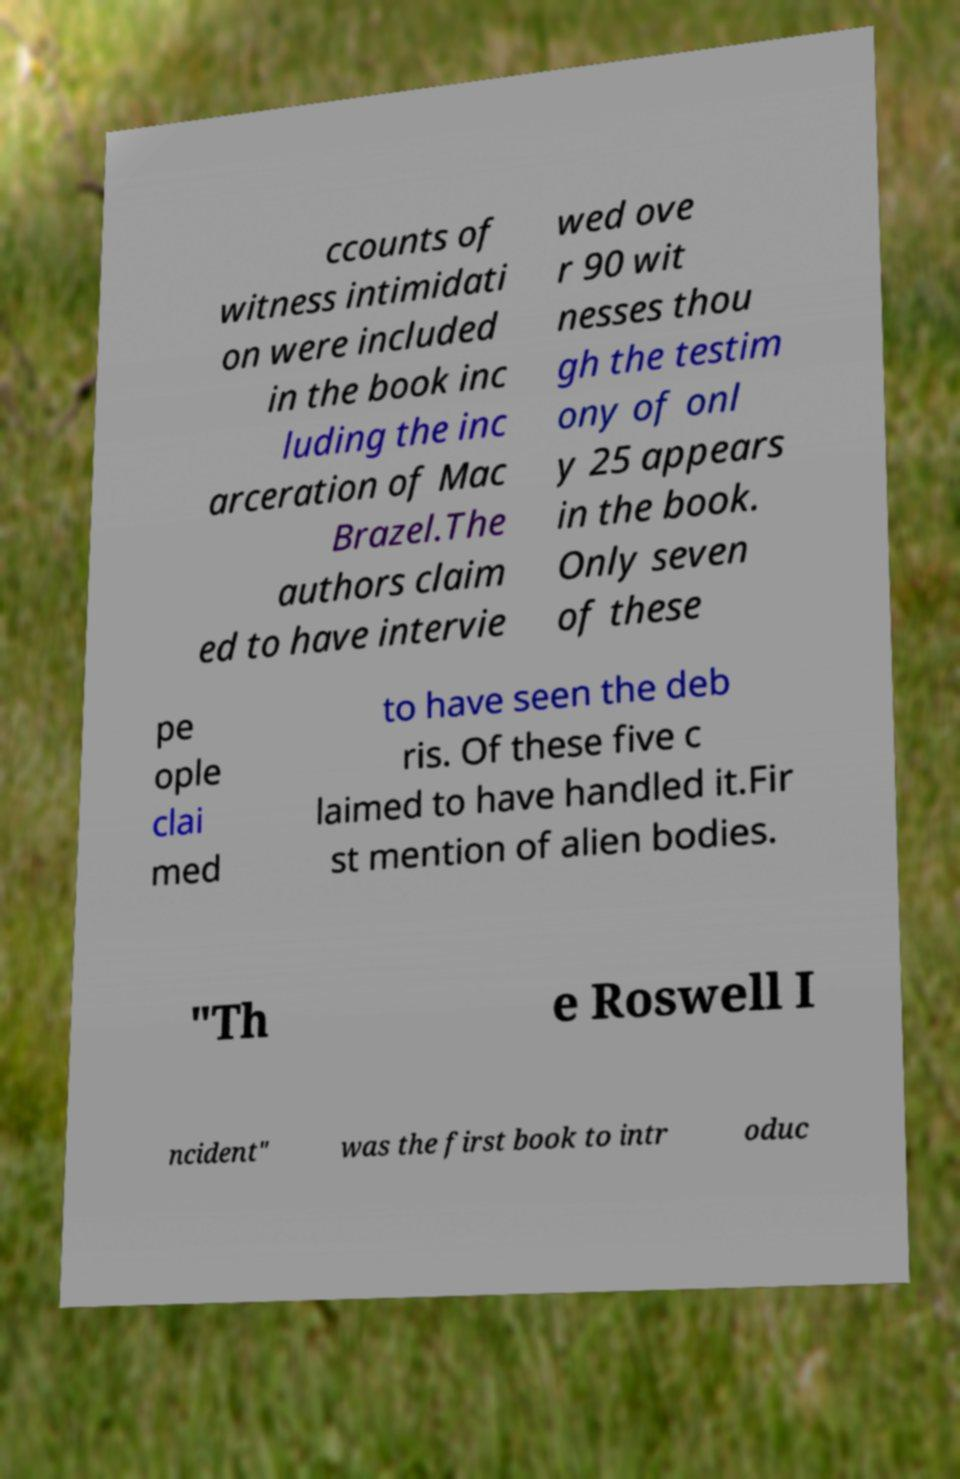Please read and relay the text visible in this image. What does it say? ccounts of witness intimidati on were included in the book inc luding the inc arceration of Mac Brazel.The authors claim ed to have intervie wed ove r 90 wit nesses thou gh the testim ony of onl y 25 appears in the book. Only seven of these pe ople clai med to have seen the deb ris. Of these five c laimed to have handled it.Fir st mention of alien bodies. "Th e Roswell I ncident" was the first book to intr oduc 